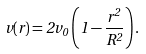Convert formula to latex. <formula><loc_0><loc_0><loc_500><loc_500>v ( r ) = 2 v _ { 0 } \left ( 1 - \frac { r ^ { 2 } } { R ^ { 2 } } \right ) .</formula> 